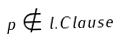Convert formula to latex. <formula><loc_0><loc_0><loc_500><loc_500>p \notin l . C l a u s e</formula> 